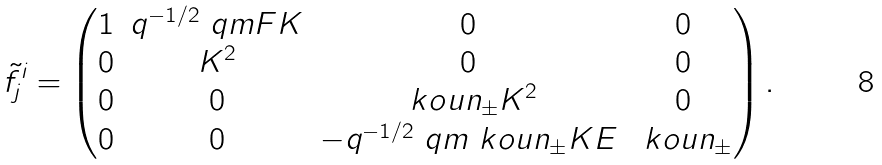<formula> <loc_0><loc_0><loc_500><loc_500>\tilde { f } ^ { i } _ { j } & = \begin{pmatrix} 1 & q ^ { - 1 / 2 } \ q m F K & 0 & 0 \\ 0 & K ^ { 2 } & 0 & 0 \\ 0 & 0 & \ k o u n _ { \pm } K ^ { 2 } & 0 \\ 0 & 0 & - q ^ { - 1 / 2 } \ q m \ k o u n _ { \pm } K E & \ k o u n _ { \pm } \end{pmatrix} .</formula> 